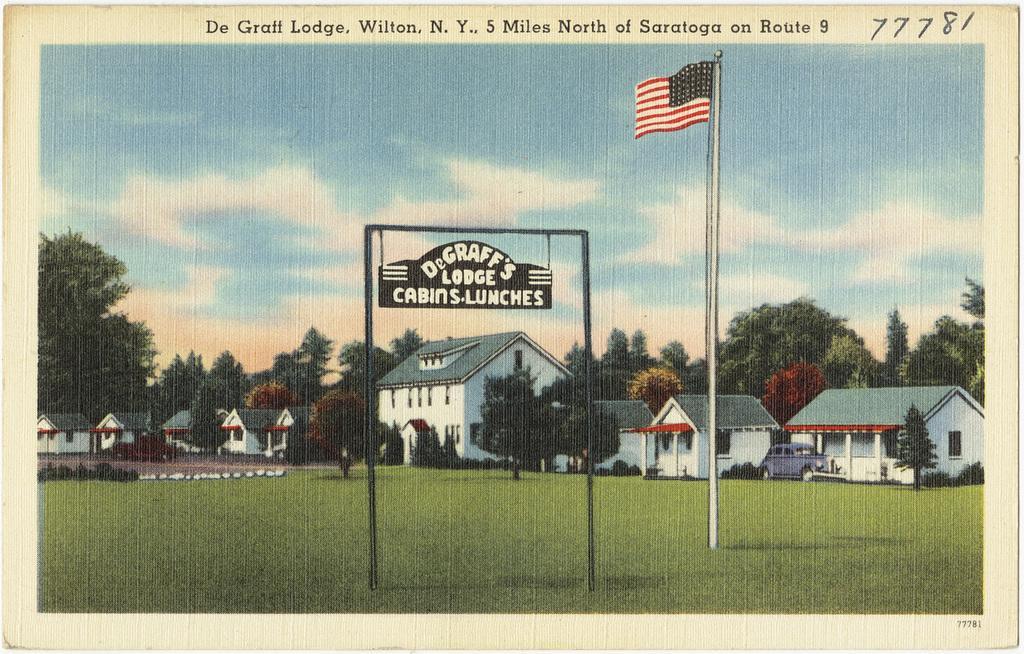How would you summarize this image in a sentence or two? In this image we can see a poster, there is an arch with a board hanged to it and there is a flag with rod, in the background there are few buildings, trees and a car parked in front of the house and the sky with clouds. 